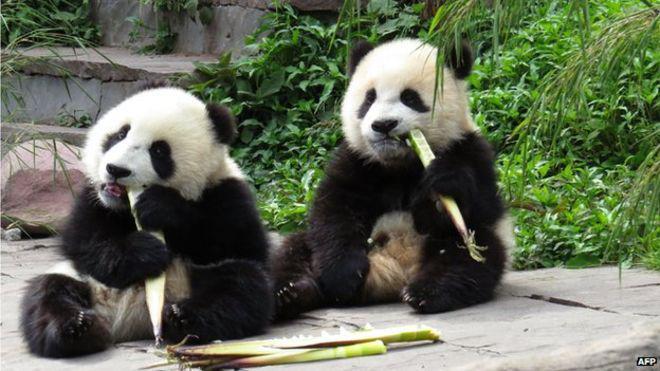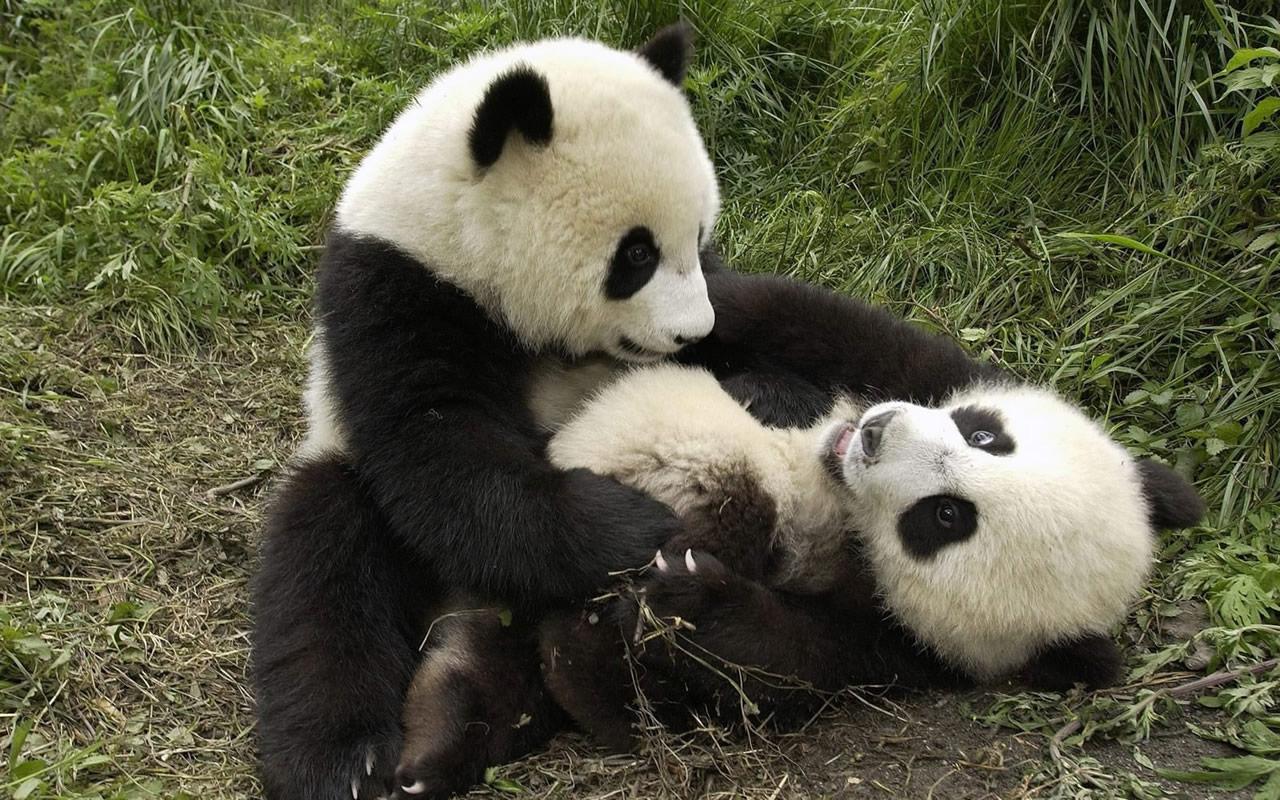The first image is the image on the left, the second image is the image on the right. Examine the images to the left and right. Is the description "One image shows pandas sitting side by side, each with a paw raised to its mouth, and the other image shows two pandas who are looking toward one another." accurate? Answer yes or no. Yes. The first image is the image on the left, the second image is the image on the right. Examine the images to the left and right. Is the description "Both images in the pair have two pandas." accurate? Answer yes or no. Yes. 